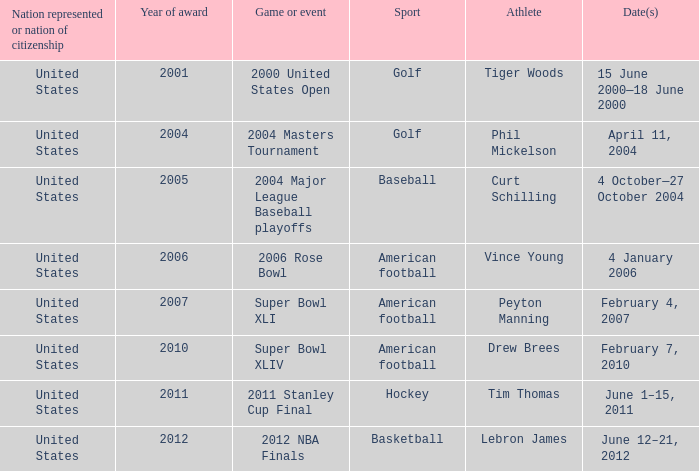In 2011 which sport had the year award? Hockey. 